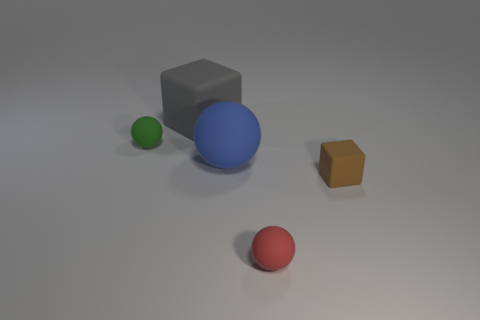There is a small brown object; is it the same shape as the big matte thing that is behind the blue thing?
Keep it short and to the point. Yes. What is the size of the red rubber object that is the same shape as the large blue rubber object?
Your answer should be compact. Small. How many other things are the same material as the gray cube?
Provide a short and direct response. 4. Is the number of small green rubber objects left of the tiny brown rubber object greater than the number of tiny purple metallic cylinders?
Your answer should be compact. Yes. What number of other objects are there of the same color as the big block?
Your answer should be very brief. 0. There is a cube that is left of the brown object; is its size the same as the blue rubber ball?
Your answer should be compact. Yes. Is there a brown matte thing of the same size as the gray object?
Your answer should be very brief. No. The tiny matte thing in front of the brown rubber object is what color?
Provide a short and direct response. Red. What shape is the rubber object that is to the right of the big gray matte object and behind the tiny cube?
Give a very brief answer. Sphere. What number of other matte things are the same shape as the small brown matte object?
Your answer should be compact. 1. 